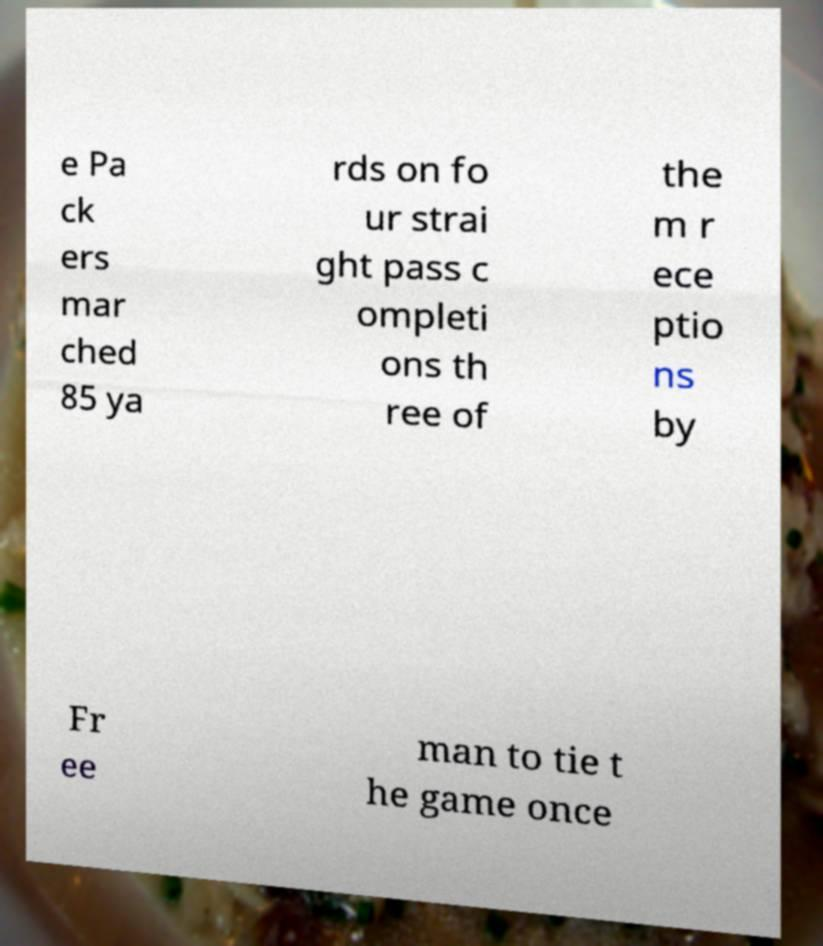Could you extract and type out the text from this image? e Pa ck ers mar ched 85 ya rds on fo ur strai ght pass c ompleti ons th ree of the m r ece ptio ns by Fr ee man to tie t he game once 